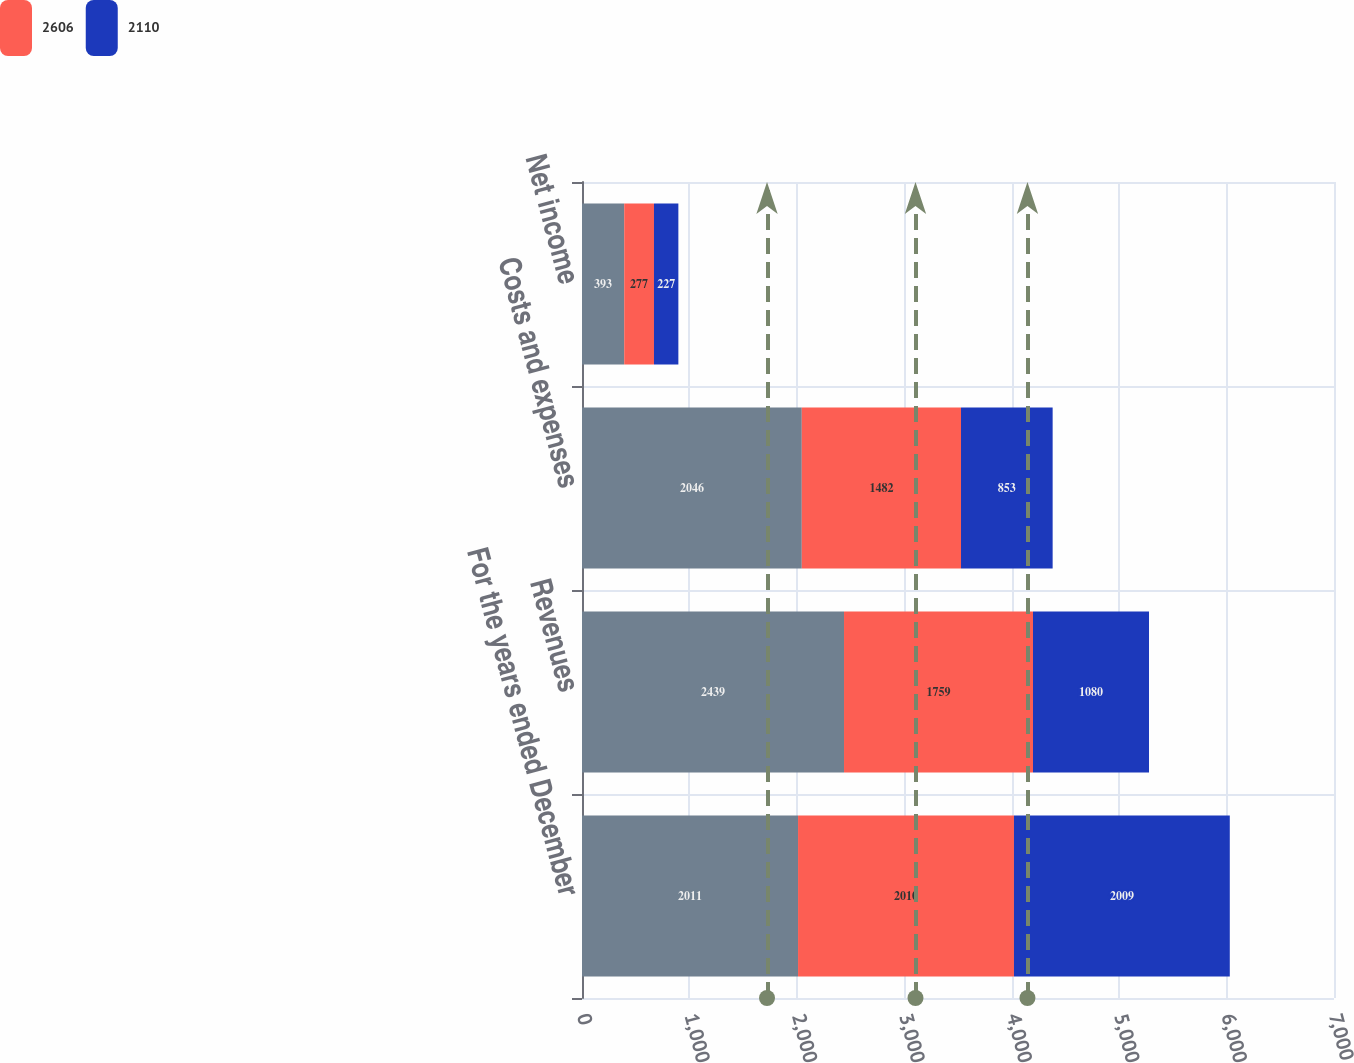Convert chart. <chart><loc_0><loc_0><loc_500><loc_500><stacked_bar_chart><ecel><fcel>For the years ended December<fcel>Revenues<fcel>Costs and expenses<fcel>Net income<nl><fcel>nan<fcel>2011<fcel>2439<fcel>2046<fcel>393<nl><fcel>2606<fcel>2010<fcel>1759<fcel>1482<fcel>277<nl><fcel>2110<fcel>2009<fcel>1080<fcel>853<fcel>227<nl></chart> 